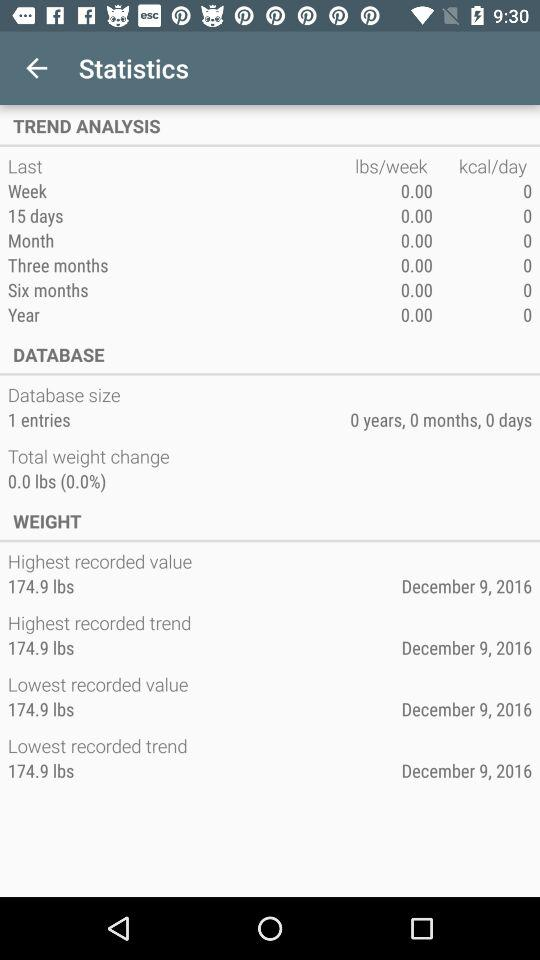What is the lowest recorded trend? The lowest recorded trend is 174.9 lbs. 